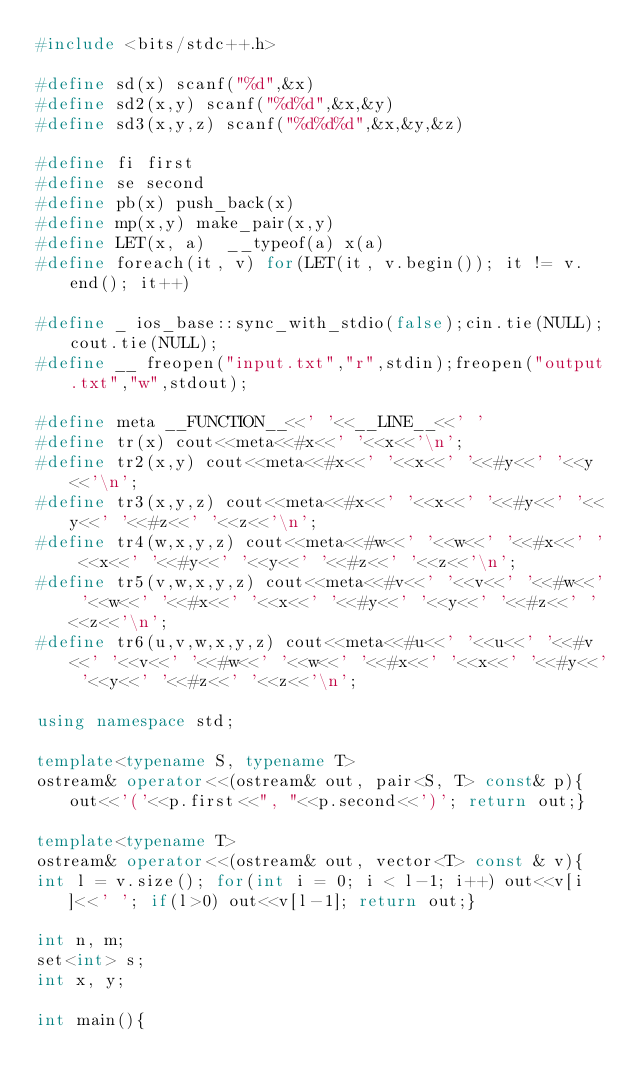<code> <loc_0><loc_0><loc_500><loc_500><_C++_>#include <bits/stdc++.h>

#define sd(x) scanf("%d",&x)
#define sd2(x,y) scanf("%d%d",&x,&y)
#define sd3(x,y,z) scanf("%d%d%d",&x,&y,&z)

#define fi first
#define se second
#define pb(x) push_back(x)
#define mp(x,y) make_pair(x,y)
#define LET(x, a)  __typeof(a) x(a)
#define foreach(it, v) for(LET(it, v.begin()); it != v.end(); it++)

#define _ ios_base::sync_with_stdio(false);cin.tie(NULL);cout.tie(NULL);
#define __ freopen("input.txt","r",stdin);freopen("output.txt","w",stdout);

#define meta __FUNCTION__<<' '<<__LINE__<<' '
#define tr(x) cout<<meta<<#x<<' '<<x<<'\n';
#define tr2(x,y) cout<<meta<<#x<<' '<<x<<' '<<#y<<' '<<y<<'\n';
#define tr3(x,y,z) cout<<meta<<#x<<' '<<x<<' '<<#y<<' '<<y<<' '<<#z<<' '<<z<<'\n';
#define tr4(w,x,y,z) cout<<meta<<#w<<' '<<w<<' '<<#x<<' ' <<x<<' '<<#y<<' '<<y<<' '<<#z<<' '<<z<<'\n';
#define tr5(v,w,x,y,z) cout<<meta<<#v<<' '<<v<<' '<<#w<<' '<<w<<' '<<#x<<' '<<x<<' '<<#y<<' '<<y<<' '<<#z<<' '<<z<<'\n';
#define tr6(u,v,w,x,y,z) cout<<meta<<#u<<' '<<u<<' '<<#v<<' '<<v<<' '<<#w<<' '<<w<<' '<<#x<<' '<<x<<' '<<#y<<' '<<y<<' '<<#z<<' '<<z<<'\n';

using namespace std;

template<typename S, typename T> 
ostream& operator<<(ostream& out, pair<S, T> const& p){out<<'('<<p.first<<", "<<p.second<<')'; return out;}

template<typename T>
ostream& operator<<(ostream& out, vector<T> const & v){
int l = v.size(); for(int i = 0; i < l-1; i++) out<<v[i]<<' '; if(l>0) out<<v[l-1]; return out;}

int n, m;
set<int> s;
int x, y;

int main(){</code> 